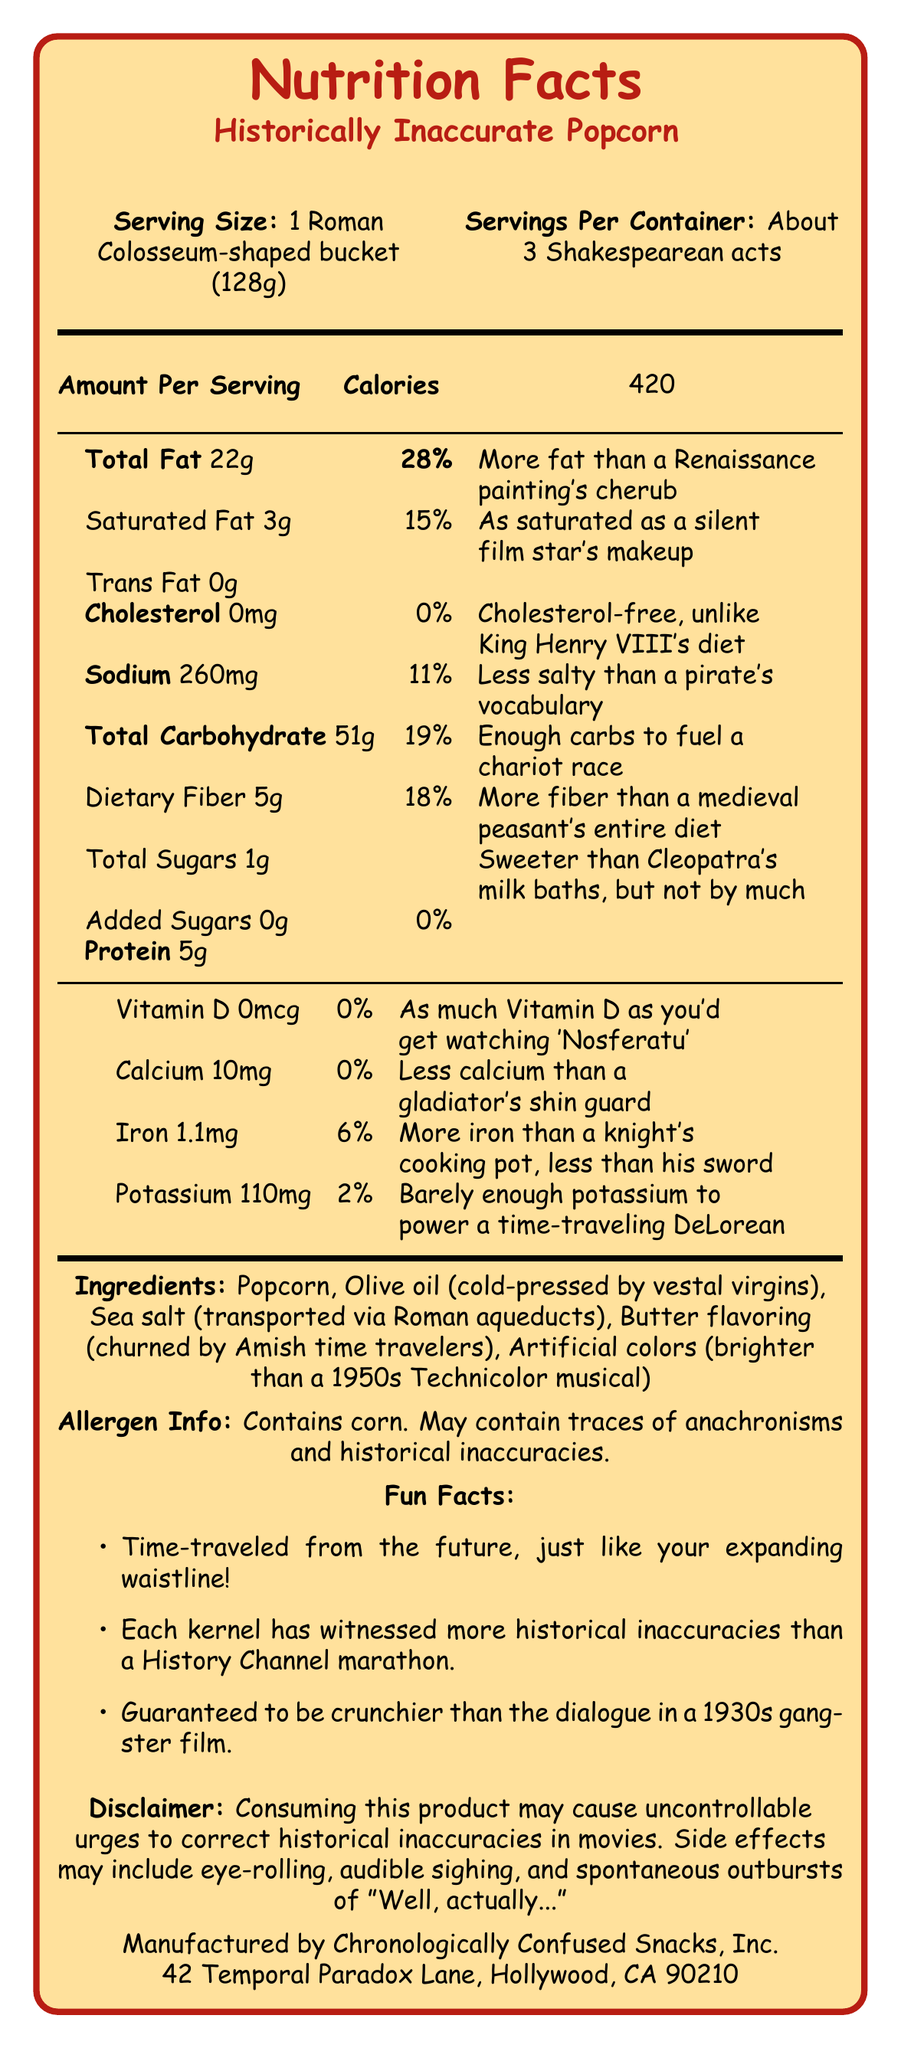How many calories are in one serving of Historically Inaccurate Popcorn? The document states that a serving of Historically Inaccurate Popcorn has 420 calories.
Answer: 420 What is the serving size for Historically Inaccurate Popcorn? The document specifies that the serving size is 1 Roman Colosseum-shaped bucket (128g).
Answer: 1 Roman Colosseum-shaped bucket (128g) What is the total fat percentage of the daily value in one serving? The document indicates that one serving contains 22g of total fat, which is 28% of the daily value.
Answer: 28% How much sodium is there in one serving of Historically Inaccurate Popcorn? The document lists 260mg of sodium per serving.
Answer: 260mg How much dietary fiber is in a serving? According to the document, a serving contains 5g of dietary fiber.
Answer: 5g Which of the following ingredients is NOT listed in Historically Inaccurate Popcorn? A. Popcorn B. Butter flavoring C. Seaweed D. Artificial colors The listed ingredients include Popcorn, Olive oil, Sea salt, Butter flavoring, and Artificial colors but not Seaweed.
Answer: C. Seaweed How does the document humorously describe the sodium content? A. Enough sodium to preserve a mummy B. Less salty than a pirate's vocabulary C. As salty as the Dead Sea D. Just as salty as your ex's attitude The document humorously states that the sodium level is "Less salty than a pirate's vocabulary."
Answer: B. Less salty than a pirate's vocabulary Is there any cholesterol in Historically Inaccurate Popcorn? The document states that there is 0mg of cholesterol, which is 0% of the daily value.
Answer: No What is the main manufacturer of Historically Inaccurate Popcorn? The document declares that the product is manufactured by Chronologically Confused Snacks, Inc.
Answer: Chronologically Confused Snacks, Inc. Summarize the entire document in a few sentences. The document gives an amusing yet informative overview of the product's nutritional content, ingredients, and several fun facts about the historically themed popcorn.
Answer: The document provides the Nutrition Facts for Historically Inaccurate Popcorn, humorously blending historical references with nutritional data: 420 calories, 22g total fat (28%), 260mg sodium (11%), and 51g carbohydrates (19%) per serving. It lists whimsical ingredients and fun facts, with a playful disclaimer and manufacturer information. What is the exact amount of Vitamin D in the product, and how does the document humorously describe it? The document notes that there is 0mcg of Vitamin D, humorously claiming it’s "As much Vitamin D as you'd get watching 'Nosferatu'."
Answer: 0mcg How many servings are there per container? The document describes that each container has about 3 servings, humorously likened to Shakespearean acts.
Answer: About 3 Shakespearean acts What is the relationship between the carbohydrate content and historical events as described in the document? The document relates the carbohydrate content to historical events by humorously stating it has "Enough carbs to fuel a chariot race."
Answer: Enough carbs to fuel a chariot race What address is listed for the manufacturer of Historically Inaccurate Popcorn? The document provides the manufacturer's address as 42 Temporal Paradox Lane, Hollywood, CA 90210.
Answer: 42 Temporal Paradox Lane, Hollywood, CA 90210 What is the dietary fiber percentage of the daily value in one serving? The document states that one serving contains 5g of dietary fiber, equivalent to 18% of the daily value.
Answer: 18% Which ingredient in the Historically Inaccurate Popcorn is associated humorously with ancient Rome? The document humorously states that the olive oil ingredient is "cold-pressed by vestal virgins."
Answer: Olive oil (cold-pressed by vestal virgins) What side effects does the document warn consumers about? The document humorously warns about side effects related to correcting historical inaccuracies, such as eye-rolling and audible sighing.
Answer: Uncontrollable urges to correct historical inaccuracies in movies, eye-rolling, audible sighing, and spontaneous outbursts of "Well, actually..." How much potassium is in each serving, and how is it humorously described? The document states that there is 110mg of potassium, humorously noting it's "Barely enough potassium to power a time-traveling DeLorean."
Answer: 110mg What is the exact amount of iron in a serving, and how does the document describe it? The document mentions that there is 1.1mg of iron, humorously saying it has "More iron than a knight's cooking pot, less than his sword."
Answer: 1.1mg What historical reference is used to describe how salty the popcorn is? The document humorously states that the sodium content is "Less salty than a pirate's vocabulary."
Answer: Less salty than a pirate's vocabulary Which ingredient is humorously stated to be transported via Roman aqueducts? The document humorously claims that the sea salt is transported via Roman aqueducts.
Answer: Sea salt What is the total sugars content in one serving of the popcorn? The document states that there is 1g of total sugars in one serving of the popcorn.
Answer: 1g What year was the company "Chronologically Confused Snacks, Inc." founded? The document does not provide any information regarding the founding year of the company.
Answer: Not enough information 